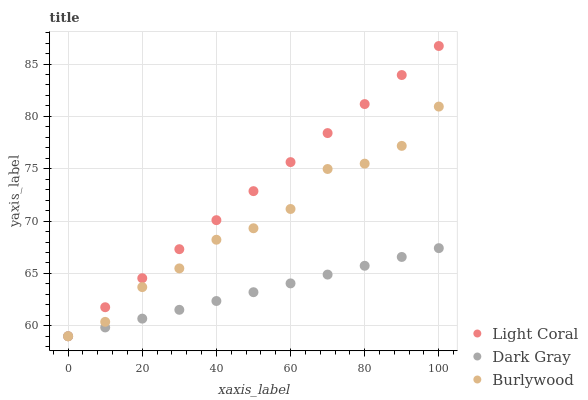Does Dark Gray have the minimum area under the curve?
Answer yes or no. Yes. Does Light Coral have the maximum area under the curve?
Answer yes or no. Yes. Does Burlywood have the minimum area under the curve?
Answer yes or no. No. Does Burlywood have the maximum area under the curve?
Answer yes or no. No. Is Dark Gray the smoothest?
Answer yes or no. Yes. Is Burlywood the roughest?
Answer yes or no. Yes. Is Burlywood the smoothest?
Answer yes or no. No. Is Dark Gray the roughest?
Answer yes or no. No. Does Light Coral have the lowest value?
Answer yes or no. Yes. Does Light Coral have the highest value?
Answer yes or no. Yes. Does Burlywood have the highest value?
Answer yes or no. No. Does Dark Gray intersect Light Coral?
Answer yes or no. Yes. Is Dark Gray less than Light Coral?
Answer yes or no. No. Is Dark Gray greater than Light Coral?
Answer yes or no. No. 